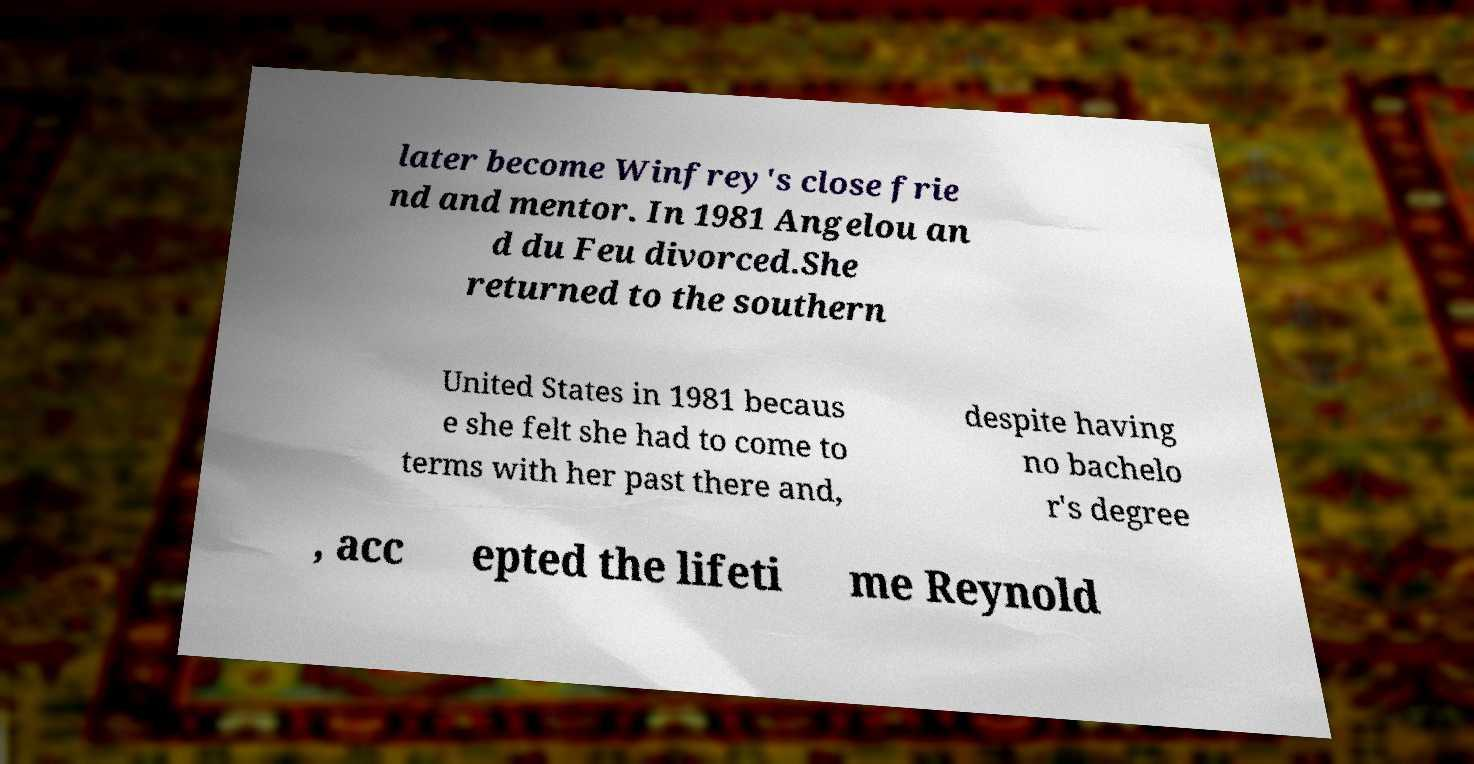For documentation purposes, I need the text within this image transcribed. Could you provide that? later become Winfrey's close frie nd and mentor. In 1981 Angelou an d du Feu divorced.She returned to the southern United States in 1981 becaus e she felt she had to come to terms with her past there and, despite having no bachelo r's degree , acc epted the lifeti me Reynold 